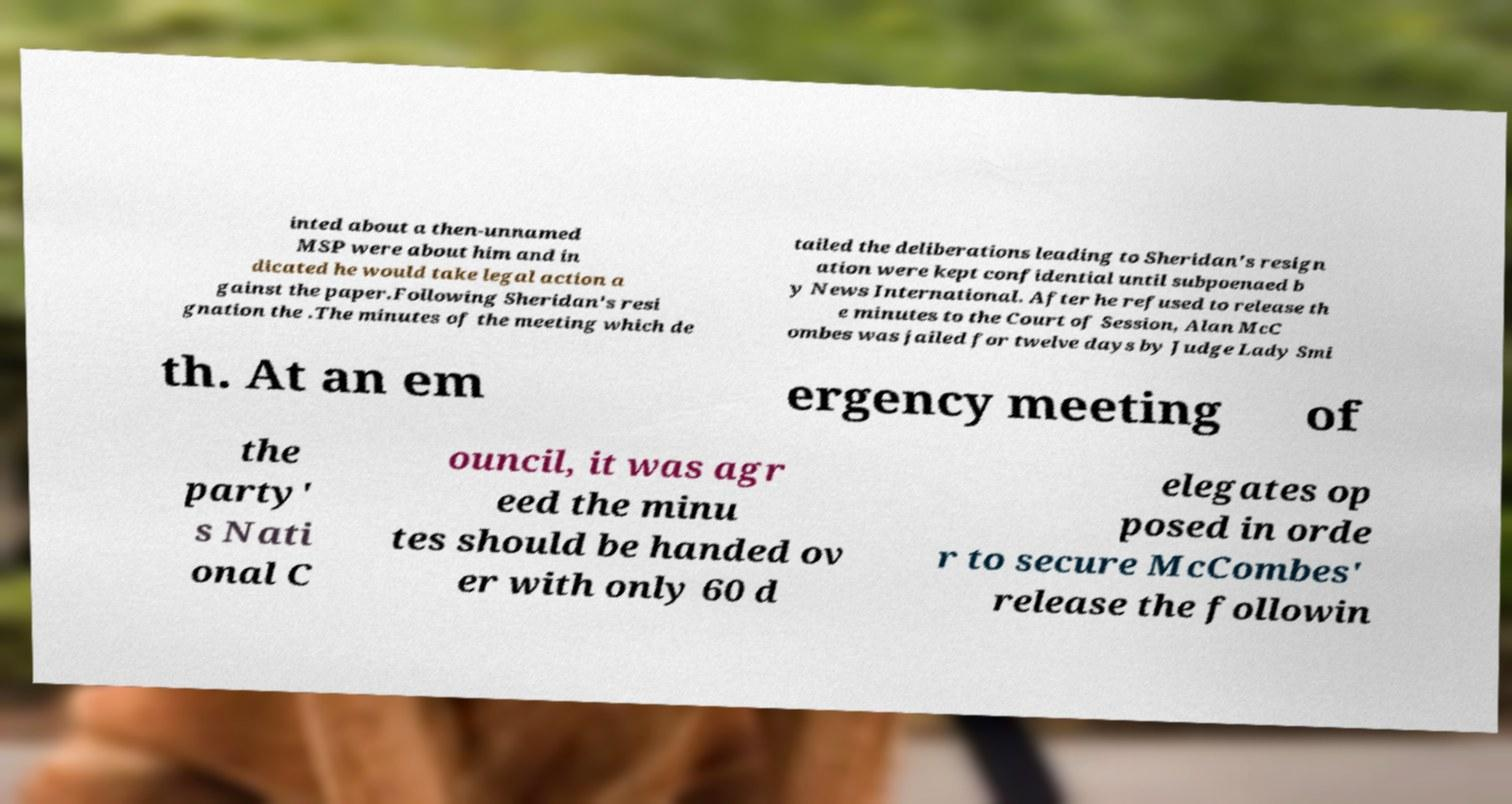What messages or text are displayed in this image? I need them in a readable, typed format. inted about a then-unnamed MSP were about him and in dicated he would take legal action a gainst the paper.Following Sheridan's resi gnation the .The minutes of the meeting which de tailed the deliberations leading to Sheridan's resign ation were kept confidential until subpoenaed b y News International. After he refused to release th e minutes to the Court of Session, Alan McC ombes was jailed for twelve days by Judge Lady Smi th. At an em ergency meeting of the party' s Nati onal C ouncil, it was agr eed the minu tes should be handed ov er with only 60 d elegates op posed in orde r to secure McCombes' release the followin 